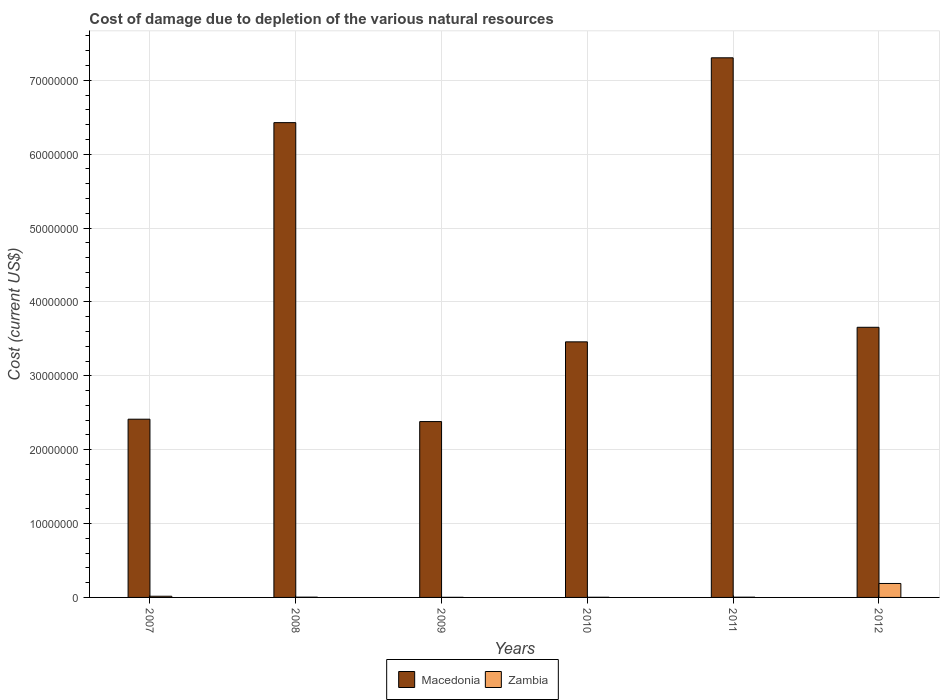Are the number of bars on each tick of the X-axis equal?
Offer a very short reply. Yes. What is the label of the 5th group of bars from the left?
Keep it short and to the point. 2011. What is the cost of damage caused due to the depletion of various natural resources in Zambia in 2009?
Provide a short and direct response. 1.19e+04. Across all years, what is the maximum cost of damage caused due to the depletion of various natural resources in Zambia?
Ensure brevity in your answer.  1.89e+06. Across all years, what is the minimum cost of damage caused due to the depletion of various natural resources in Macedonia?
Offer a very short reply. 2.38e+07. In which year was the cost of damage caused due to the depletion of various natural resources in Macedonia maximum?
Provide a short and direct response. 2011. What is the total cost of damage caused due to the depletion of various natural resources in Macedonia in the graph?
Keep it short and to the point. 2.56e+08. What is the difference between the cost of damage caused due to the depletion of various natural resources in Macedonia in 2008 and that in 2009?
Your response must be concise. 4.05e+07. What is the difference between the cost of damage caused due to the depletion of various natural resources in Zambia in 2011 and the cost of damage caused due to the depletion of various natural resources in Macedonia in 2009?
Keep it short and to the point. -2.38e+07. What is the average cost of damage caused due to the depletion of various natural resources in Zambia per year?
Your response must be concise. 3.58e+05. In the year 2010, what is the difference between the cost of damage caused due to the depletion of various natural resources in Zambia and cost of damage caused due to the depletion of various natural resources in Macedonia?
Your response must be concise. -3.46e+07. What is the ratio of the cost of damage caused due to the depletion of various natural resources in Zambia in 2007 to that in 2010?
Give a very brief answer. 7.46. What is the difference between the highest and the second highest cost of damage caused due to the depletion of various natural resources in Macedonia?
Your answer should be compact. 8.77e+06. What is the difference between the highest and the lowest cost of damage caused due to the depletion of various natural resources in Zambia?
Provide a succinct answer. 1.88e+06. What does the 1st bar from the left in 2012 represents?
Keep it short and to the point. Macedonia. What does the 1st bar from the right in 2010 represents?
Provide a short and direct response. Zambia. How many bars are there?
Your answer should be very brief. 12. Are all the bars in the graph horizontal?
Your answer should be very brief. No. How many years are there in the graph?
Your response must be concise. 6. Are the values on the major ticks of Y-axis written in scientific E-notation?
Ensure brevity in your answer.  No. Where does the legend appear in the graph?
Provide a short and direct response. Bottom center. How many legend labels are there?
Your answer should be very brief. 2. How are the legend labels stacked?
Make the answer very short. Horizontal. What is the title of the graph?
Your answer should be very brief. Cost of damage due to depletion of the various natural resources. What is the label or title of the X-axis?
Provide a succinct answer. Years. What is the label or title of the Y-axis?
Your response must be concise. Cost (current US$). What is the Cost (current US$) in Macedonia in 2007?
Ensure brevity in your answer.  2.41e+07. What is the Cost (current US$) of Zambia in 2007?
Your answer should be compact. 1.61e+05. What is the Cost (current US$) of Macedonia in 2008?
Give a very brief answer. 6.43e+07. What is the Cost (current US$) in Zambia in 2008?
Your response must be concise. 3.53e+04. What is the Cost (current US$) in Macedonia in 2009?
Provide a succinct answer. 2.38e+07. What is the Cost (current US$) of Zambia in 2009?
Your answer should be very brief. 1.19e+04. What is the Cost (current US$) of Macedonia in 2010?
Keep it short and to the point. 3.46e+07. What is the Cost (current US$) of Zambia in 2010?
Offer a terse response. 2.16e+04. What is the Cost (current US$) in Macedonia in 2011?
Make the answer very short. 7.30e+07. What is the Cost (current US$) of Zambia in 2011?
Offer a very short reply. 3.14e+04. What is the Cost (current US$) of Macedonia in 2012?
Give a very brief answer. 3.66e+07. What is the Cost (current US$) in Zambia in 2012?
Provide a succinct answer. 1.89e+06. Across all years, what is the maximum Cost (current US$) of Macedonia?
Give a very brief answer. 7.30e+07. Across all years, what is the maximum Cost (current US$) of Zambia?
Your answer should be compact. 1.89e+06. Across all years, what is the minimum Cost (current US$) of Macedonia?
Your response must be concise. 2.38e+07. Across all years, what is the minimum Cost (current US$) of Zambia?
Your answer should be very brief. 1.19e+04. What is the total Cost (current US$) of Macedonia in the graph?
Your answer should be very brief. 2.56e+08. What is the total Cost (current US$) in Zambia in the graph?
Your answer should be compact. 2.15e+06. What is the difference between the Cost (current US$) in Macedonia in 2007 and that in 2008?
Your answer should be compact. -4.01e+07. What is the difference between the Cost (current US$) in Zambia in 2007 and that in 2008?
Your answer should be compact. 1.26e+05. What is the difference between the Cost (current US$) of Macedonia in 2007 and that in 2009?
Keep it short and to the point. 3.22e+05. What is the difference between the Cost (current US$) of Zambia in 2007 and that in 2009?
Offer a very short reply. 1.49e+05. What is the difference between the Cost (current US$) in Macedonia in 2007 and that in 2010?
Ensure brevity in your answer.  -1.05e+07. What is the difference between the Cost (current US$) of Zambia in 2007 and that in 2010?
Give a very brief answer. 1.39e+05. What is the difference between the Cost (current US$) in Macedonia in 2007 and that in 2011?
Give a very brief answer. -4.89e+07. What is the difference between the Cost (current US$) of Zambia in 2007 and that in 2011?
Provide a succinct answer. 1.30e+05. What is the difference between the Cost (current US$) in Macedonia in 2007 and that in 2012?
Make the answer very short. -1.24e+07. What is the difference between the Cost (current US$) of Zambia in 2007 and that in 2012?
Provide a short and direct response. -1.73e+06. What is the difference between the Cost (current US$) in Macedonia in 2008 and that in 2009?
Provide a short and direct response. 4.05e+07. What is the difference between the Cost (current US$) of Zambia in 2008 and that in 2009?
Ensure brevity in your answer.  2.34e+04. What is the difference between the Cost (current US$) of Macedonia in 2008 and that in 2010?
Keep it short and to the point. 2.97e+07. What is the difference between the Cost (current US$) of Zambia in 2008 and that in 2010?
Provide a succinct answer. 1.38e+04. What is the difference between the Cost (current US$) in Macedonia in 2008 and that in 2011?
Offer a terse response. -8.77e+06. What is the difference between the Cost (current US$) in Zambia in 2008 and that in 2011?
Your answer should be compact. 3896.36. What is the difference between the Cost (current US$) of Macedonia in 2008 and that in 2012?
Provide a short and direct response. 2.77e+07. What is the difference between the Cost (current US$) in Zambia in 2008 and that in 2012?
Provide a short and direct response. -1.85e+06. What is the difference between the Cost (current US$) in Macedonia in 2009 and that in 2010?
Offer a terse response. -1.08e+07. What is the difference between the Cost (current US$) of Zambia in 2009 and that in 2010?
Give a very brief answer. -9682.72. What is the difference between the Cost (current US$) in Macedonia in 2009 and that in 2011?
Give a very brief answer. -4.92e+07. What is the difference between the Cost (current US$) of Zambia in 2009 and that in 2011?
Your answer should be very brief. -1.95e+04. What is the difference between the Cost (current US$) of Macedonia in 2009 and that in 2012?
Your response must be concise. -1.28e+07. What is the difference between the Cost (current US$) in Zambia in 2009 and that in 2012?
Provide a succinct answer. -1.88e+06. What is the difference between the Cost (current US$) of Macedonia in 2010 and that in 2011?
Make the answer very short. -3.85e+07. What is the difference between the Cost (current US$) in Zambia in 2010 and that in 2011?
Offer a terse response. -9863.62. What is the difference between the Cost (current US$) of Macedonia in 2010 and that in 2012?
Ensure brevity in your answer.  -1.97e+06. What is the difference between the Cost (current US$) in Zambia in 2010 and that in 2012?
Keep it short and to the point. -1.87e+06. What is the difference between the Cost (current US$) of Macedonia in 2011 and that in 2012?
Provide a short and direct response. 3.65e+07. What is the difference between the Cost (current US$) in Zambia in 2011 and that in 2012?
Your response must be concise. -1.86e+06. What is the difference between the Cost (current US$) in Macedonia in 2007 and the Cost (current US$) in Zambia in 2008?
Your answer should be very brief. 2.41e+07. What is the difference between the Cost (current US$) of Macedonia in 2007 and the Cost (current US$) of Zambia in 2009?
Your answer should be very brief. 2.41e+07. What is the difference between the Cost (current US$) of Macedonia in 2007 and the Cost (current US$) of Zambia in 2010?
Make the answer very short. 2.41e+07. What is the difference between the Cost (current US$) of Macedonia in 2007 and the Cost (current US$) of Zambia in 2011?
Provide a succinct answer. 2.41e+07. What is the difference between the Cost (current US$) of Macedonia in 2007 and the Cost (current US$) of Zambia in 2012?
Provide a short and direct response. 2.22e+07. What is the difference between the Cost (current US$) of Macedonia in 2008 and the Cost (current US$) of Zambia in 2009?
Offer a terse response. 6.43e+07. What is the difference between the Cost (current US$) in Macedonia in 2008 and the Cost (current US$) in Zambia in 2010?
Keep it short and to the point. 6.43e+07. What is the difference between the Cost (current US$) in Macedonia in 2008 and the Cost (current US$) in Zambia in 2011?
Ensure brevity in your answer.  6.42e+07. What is the difference between the Cost (current US$) in Macedonia in 2008 and the Cost (current US$) in Zambia in 2012?
Your answer should be compact. 6.24e+07. What is the difference between the Cost (current US$) of Macedonia in 2009 and the Cost (current US$) of Zambia in 2010?
Ensure brevity in your answer.  2.38e+07. What is the difference between the Cost (current US$) of Macedonia in 2009 and the Cost (current US$) of Zambia in 2011?
Provide a short and direct response. 2.38e+07. What is the difference between the Cost (current US$) of Macedonia in 2009 and the Cost (current US$) of Zambia in 2012?
Offer a very short reply. 2.19e+07. What is the difference between the Cost (current US$) in Macedonia in 2010 and the Cost (current US$) in Zambia in 2011?
Keep it short and to the point. 3.46e+07. What is the difference between the Cost (current US$) of Macedonia in 2010 and the Cost (current US$) of Zambia in 2012?
Your answer should be very brief. 3.27e+07. What is the difference between the Cost (current US$) in Macedonia in 2011 and the Cost (current US$) in Zambia in 2012?
Make the answer very short. 7.12e+07. What is the average Cost (current US$) of Macedonia per year?
Keep it short and to the point. 4.27e+07. What is the average Cost (current US$) in Zambia per year?
Your response must be concise. 3.58e+05. In the year 2007, what is the difference between the Cost (current US$) in Macedonia and Cost (current US$) in Zambia?
Give a very brief answer. 2.40e+07. In the year 2008, what is the difference between the Cost (current US$) in Macedonia and Cost (current US$) in Zambia?
Your response must be concise. 6.42e+07. In the year 2009, what is the difference between the Cost (current US$) in Macedonia and Cost (current US$) in Zambia?
Your response must be concise. 2.38e+07. In the year 2010, what is the difference between the Cost (current US$) in Macedonia and Cost (current US$) in Zambia?
Provide a short and direct response. 3.46e+07. In the year 2011, what is the difference between the Cost (current US$) in Macedonia and Cost (current US$) in Zambia?
Offer a terse response. 7.30e+07. In the year 2012, what is the difference between the Cost (current US$) in Macedonia and Cost (current US$) in Zambia?
Provide a succinct answer. 3.47e+07. What is the ratio of the Cost (current US$) in Macedonia in 2007 to that in 2008?
Your answer should be very brief. 0.38. What is the ratio of the Cost (current US$) in Zambia in 2007 to that in 2008?
Make the answer very short. 4.56. What is the ratio of the Cost (current US$) in Macedonia in 2007 to that in 2009?
Your response must be concise. 1.01. What is the ratio of the Cost (current US$) in Zambia in 2007 to that in 2009?
Ensure brevity in your answer.  13.54. What is the ratio of the Cost (current US$) in Macedonia in 2007 to that in 2010?
Provide a short and direct response. 0.7. What is the ratio of the Cost (current US$) in Zambia in 2007 to that in 2010?
Provide a succinct answer. 7.46. What is the ratio of the Cost (current US$) in Macedonia in 2007 to that in 2011?
Your answer should be compact. 0.33. What is the ratio of the Cost (current US$) of Zambia in 2007 to that in 2011?
Provide a succinct answer. 5.12. What is the ratio of the Cost (current US$) of Macedonia in 2007 to that in 2012?
Provide a succinct answer. 0.66. What is the ratio of the Cost (current US$) in Zambia in 2007 to that in 2012?
Ensure brevity in your answer.  0.09. What is the ratio of the Cost (current US$) in Macedonia in 2008 to that in 2009?
Keep it short and to the point. 2.7. What is the ratio of the Cost (current US$) of Zambia in 2008 to that in 2009?
Offer a very short reply. 2.97. What is the ratio of the Cost (current US$) of Macedonia in 2008 to that in 2010?
Ensure brevity in your answer.  1.86. What is the ratio of the Cost (current US$) of Zambia in 2008 to that in 2010?
Offer a very short reply. 1.64. What is the ratio of the Cost (current US$) of Macedonia in 2008 to that in 2011?
Your response must be concise. 0.88. What is the ratio of the Cost (current US$) in Zambia in 2008 to that in 2011?
Keep it short and to the point. 1.12. What is the ratio of the Cost (current US$) in Macedonia in 2008 to that in 2012?
Provide a succinct answer. 1.76. What is the ratio of the Cost (current US$) in Zambia in 2008 to that in 2012?
Keep it short and to the point. 0.02. What is the ratio of the Cost (current US$) in Macedonia in 2009 to that in 2010?
Your answer should be compact. 0.69. What is the ratio of the Cost (current US$) in Zambia in 2009 to that in 2010?
Your answer should be very brief. 0.55. What is the ratio of the Cost (current US$) of Macedonia in 2009 to that in 2011?
Offer a very short reply. 0.33. What is the ratio of the Cost (current US$) in Zambia in 2009 to that in 2011?
Your answer should be very brief. 0.38. What is the ratio of the Cost (current US$) in Macedonia in 2009 to that in 2012?
Your answer should be very brief. 0.65. What is the ratio of the Cost (current US$) in Zambia in 2009 to that in 2012?
Offer a terse response. 0.01. What is the ratio of the Cost (current US$) of Macedonia in 2010 to that in 2011?
Ensure brevity in your answer.  0.47. What is the ratio of the Cost (current US$) of Zambia in 2010 to that in 2011?
Ensure brevity in your answer.  0.69. What is the ratio of the Cost (current US$) of Macedonia in 2010 to that in 2012?
Make the answer very short. 0.95. What is the ratio of the Cost (current US$) of Zambia in 2010 to that in 2012?
Provide a short and direct response. 0.01. What is the ratio of the Cost (current US$) of Macedonia in 2011 to that in 2012?
Ensure brevity in your answer.  2. What is the ratio of the Cost (current US$) of Zambia in 2011 to that in 2012?
Your answer should be compact. 0.02. What is the difference between the highest and the second highest Cost (current US$) in Macedonia?
Provide a short and direct response. 8.77e+06. What is the difference between the highest and the second highest Cost (current US$) in Zambia?
Provide a short and direct response. 1.73e+06. What is the difference between the highest and the lowest Cost (current US$) in Macedonia?
Give a very brief answer. 4.92e+07. What is the difference between the highest and the lowest Cost (current US$) in Zambia?
Your answer should be compact. 1.88e+06. 